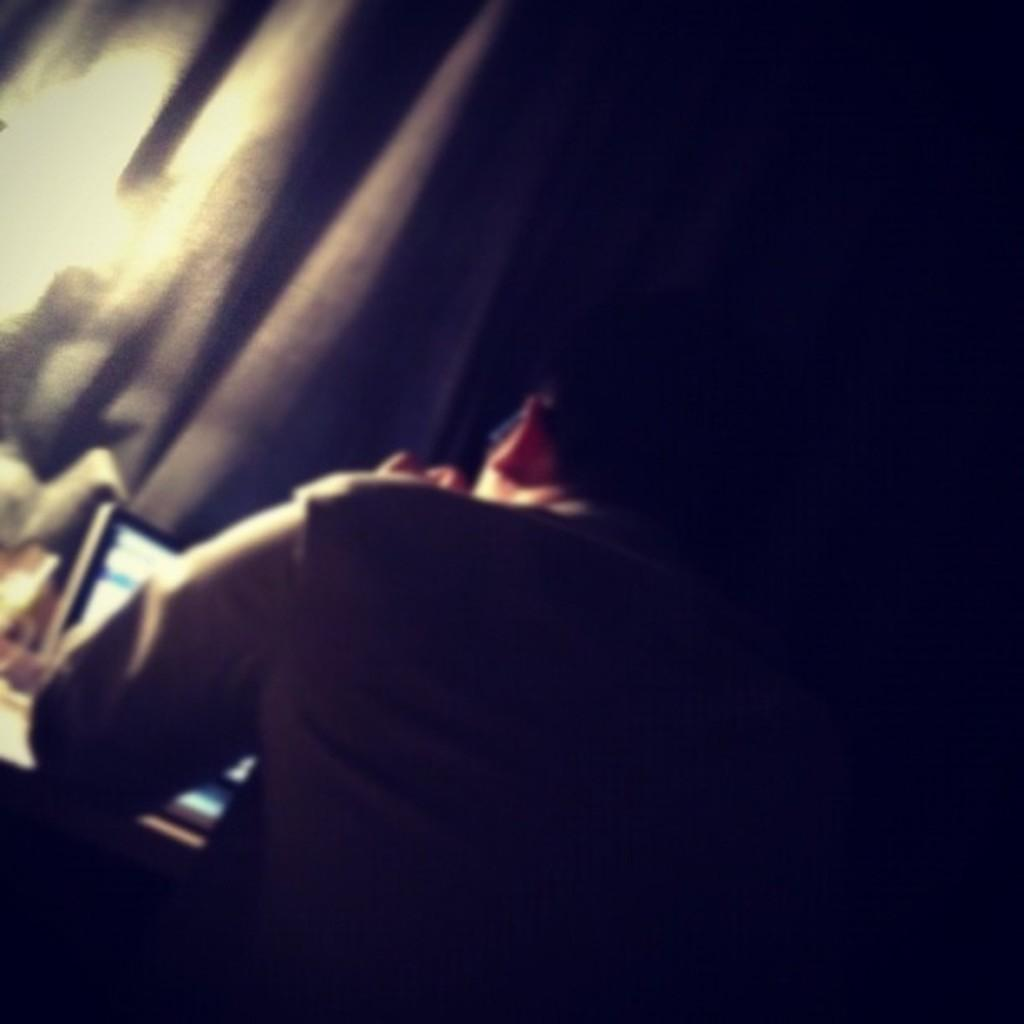What is the main subject of the image? There is a man in the image. What is the man doing in the image? The man is working on a laptop. Can you see a sneeze happening in the image? No, there is no sneeze present in the image. What type of cloud can be seen in the image? There are no clouds visible in the image, as it features a man working on a laptop. 